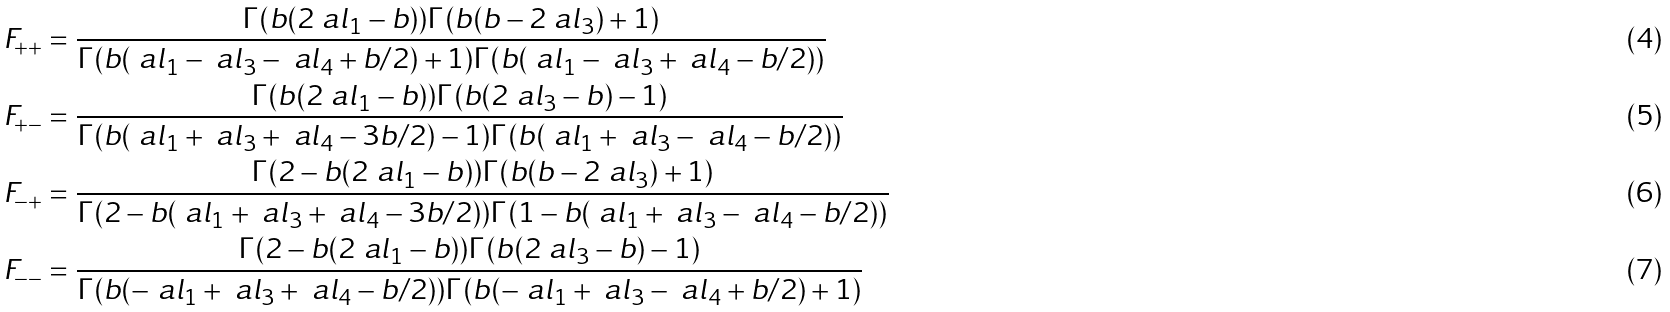<formula> <loc_0><loc_0><loc_500><loc_500>F _ { + + } & = \frac { \Gamma ( b ( 2 \ a l _ { 1 } - b ) ) \Gamma ( b ( b - 2 \ a l _ { 3 } ) + 1 ) } { \Gamma ( b ( \ a l _ { 1 } - \ a l _ { 3 } - \ a l _ { 4 } + b / 2 ) + 1 ) \Gamma ( b ( \ a l _ { 1 } - \ a l _ { 3 } + \ a l _ { 4 } - b / 2 ) ) } \\ F _ { + - } & = \frac { \Gamma ( b ( 2 \ a l _ { 1 } - b ) ) \Gamma ( b ( 2 \ a l _ { 3 } - b ) - 1 ) } { \Gamma ( b ( \ a l _ { 1 } + \ a l _ { 3 } + \ a l _ { 4 } - 3 b / 2 ) - 1 ) \Gamma ( b ( \ a l _ { 1 } + \ a l _ { 3 } - \ a l _ { 4 } - b / 2 ) ) } \\ F _ { - + } & = \frac { \Gamma ( 2 - b ( 2 \ a l _ { 1 } - b ) ) \Gamma ( b ( b - 2 \ a l _ { 3 } ) + 1 ) } { \Gamma ( 2 - b ( \ a l _ { 1 } + \ a l _ { 3 } + \ a l _ { 4 } - 3 b / 2 ) ) \Gamma ( 1 - b ( \ a l _ { 1 } + \ a l _ { 3 } - \ a l _ { 4 } - b / 2 ) ) } \\ F _ { - - } & = \frac { \Gamma ( 2 - b ( 2 \ a l _ { 1 } - b ) ) \Gamma ( b ( 2 \ a l _ { 3 } - b ) - 1 ) } { \Gamma ( b ( - \ a l _ { 1 } + \ a l _ { 3 } + \ a l _ { 4 } - b / 2 ) ) \Gamma ( b ( - \ a l _ { 1 } + \ a l _ { 3 } - \ a l _ { 4 } + b / 2 ) + 1 ) }</formula> 